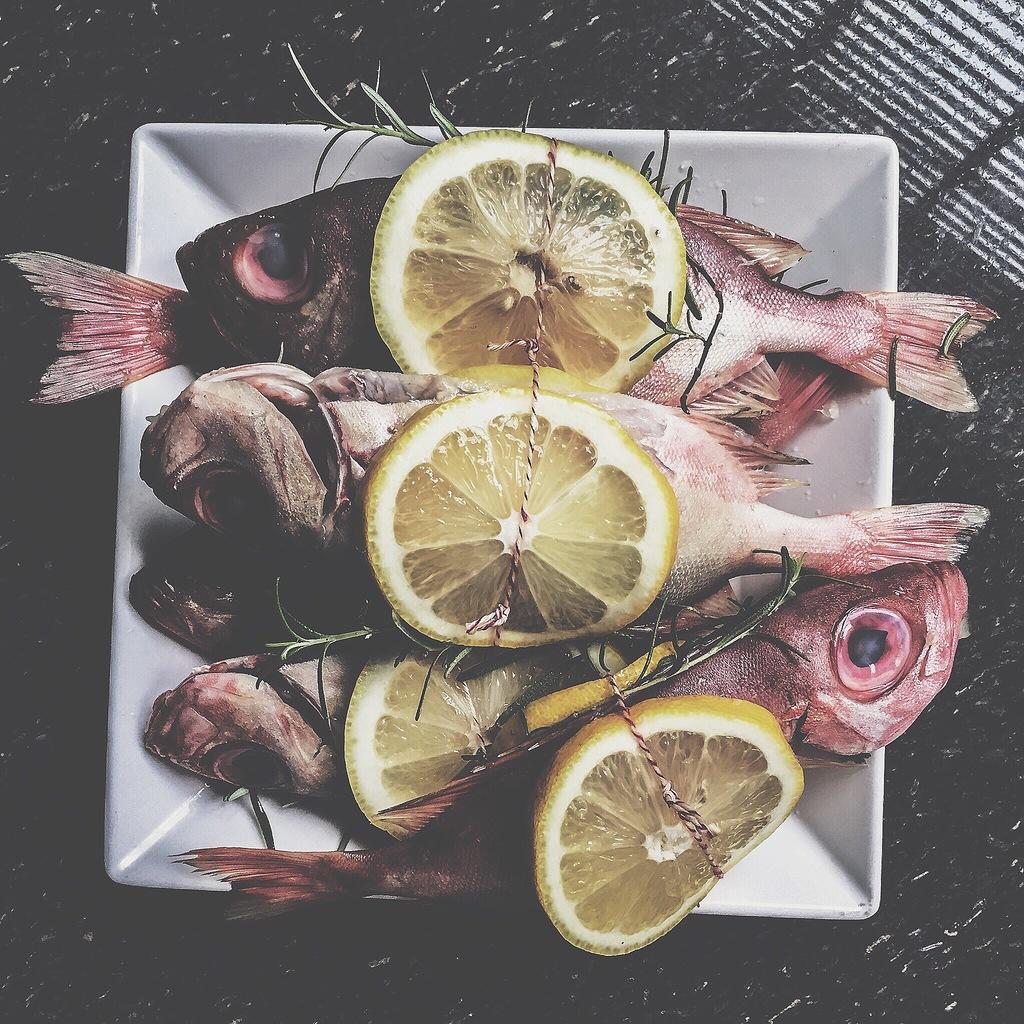Could you give a brief overview of what you see in this image? In this image I can see fishes and few lemons in the plate and the plate is in white color 